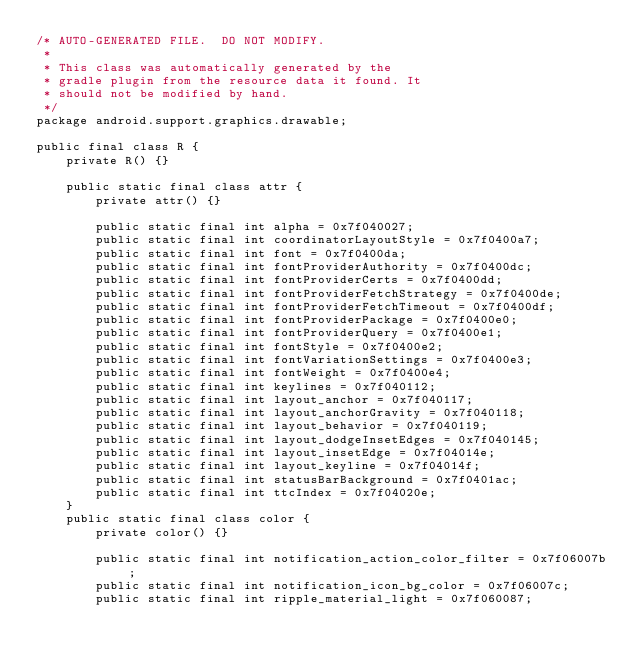<code> <loc_0><loc_0><loc_500><loc_500><_Java_>/* AUTO-GENERATED FILE.  DO NOT MODIFY.
 *
 * This class was automatically generated by the
 * gradle plugin from the resource data it found. It
 * should not be modified by hand.
 */
package android.support.graphics.drawable;

public final class R {
    private R() {}

    public static final class attr {
        private attr() {}

        public static final int alpha = 0x7f040027;
        public static final int coordinatorLayoutStyle = 0x7f0400a7;
        public static final int font = 0x7f0400da;
        public static final int fontProviderAuthority = 0x7f0400dc;
        public static final int fontProviderCerts = 0x7f0400dd;
        public static final int fontProviderFetchStrategy = 0x7f0400de;
        public static final int fontProviderFetchTimeout = 0x7f0400df;
        public static final int fontProviderPackage = 0x7f0400e0;
        public static final int fontProviderQuery = 0x7f0400e1;
        public static final int fontStyle = 0x7f0400e2;
        public static final int fontVariationSettings = 0x7f0400e3;
        public static final int fontWeight = 0x7f0400e4;
        public static final int keylines = 0x7f040112;
        public static final int layout_anchor = 0x7f040117;
        public static final int layout_anchorGravity = 0x7f040118;
        public static final int layout_behavior = 0x7f040119;
        public static final int layout_dodgeInsetEdges = 0x7f040145;
        public static final int layout_insetEdge = 0x7f04014e;
        public static final int layout_keyline = 0x7f04014f;
        public static final int statusBarBackground = 0x7f0401ac;
        public static final int ttcIndex = 0x7f04020e;
    }
    public static final class color {
        private color() {}

        public static final int notification_action_color_filter = 0x7f06007b;
        public static final int notification_icon_bg_color = 0x7f06007c;
        public static final int ripple_material_light = 0x7f060087;</code> 